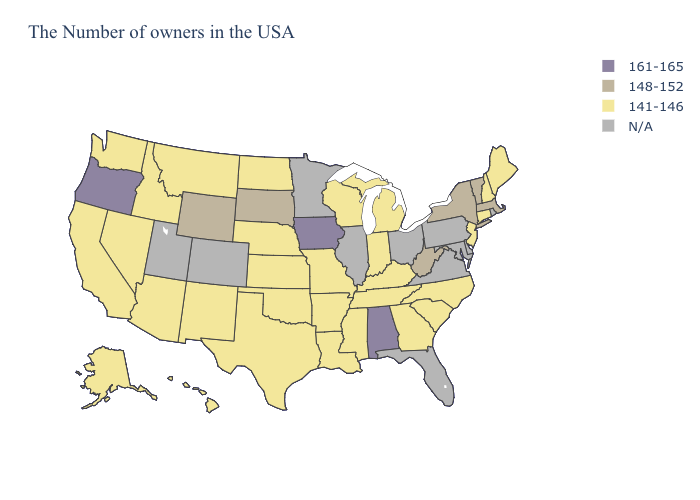Name the states that have a value in the range N/A?
Give a very brief answer. Rhode Island, Delaware, Maryland, Pennsylvania, Virginia, Ohio, Florida, Illinois, Minnesota, Colorado, Utah. Among the states that border Minnesota , does Iowa have the highest value?
Write a very short answer. Yes. What is the highest value in the USA?
Concise answer only. 161-165. Does Vermont have the lowest value in the USA?
Short answer required. No. Does the first symbol in the legend represent the smallest category?
Be succinct. No. Name the states that have a value in the range 141-146?
Quick response, please. Maine, New Hampshire, Connecticut, New Jersey, North Carolina, South Carolina, Georgia, Michigan, Kentucky, Indiana, Tennessee, Wisconsin, Mississippi, Louisiana, Missouri, Arkansas, Kansas, Nebraska, Oklahoma, Texas, North Dakota, New Mexico, Montana, Arizona, Idaho, Nevada, California, Washington, Alaska, Hawaii. Does South Dakota have the lowest value in the MidWest?
Concise answer only. No. Does Missouri have the highest value in the USA?
Concise answer only. No. Name the states that have a value in the range N/A?
Be succinct. Rhode Island, Delaware, Maryland, Pennsylvania, Virginia, Ohio, Florida, Illinois, Minnesota, Colorado, Utah. What is the value of Iowa?
Write a very short answer. 161-165. Name the states that have a value in the range 161-165?
Concise answer only. Alabama, Iowa, Oregon. What is the lowest value in the USA?
Write a very short answer. 141-146. Is the legend a continuous bar?
Be succinct. No. Name the states that have a value in the range 148-152?
Concise answer only. Massachusetts, Vermont, New York, West Virginia, South Dakota, Wyoming. What is the highest value in the West ?
Answer briefly. 161-165. 